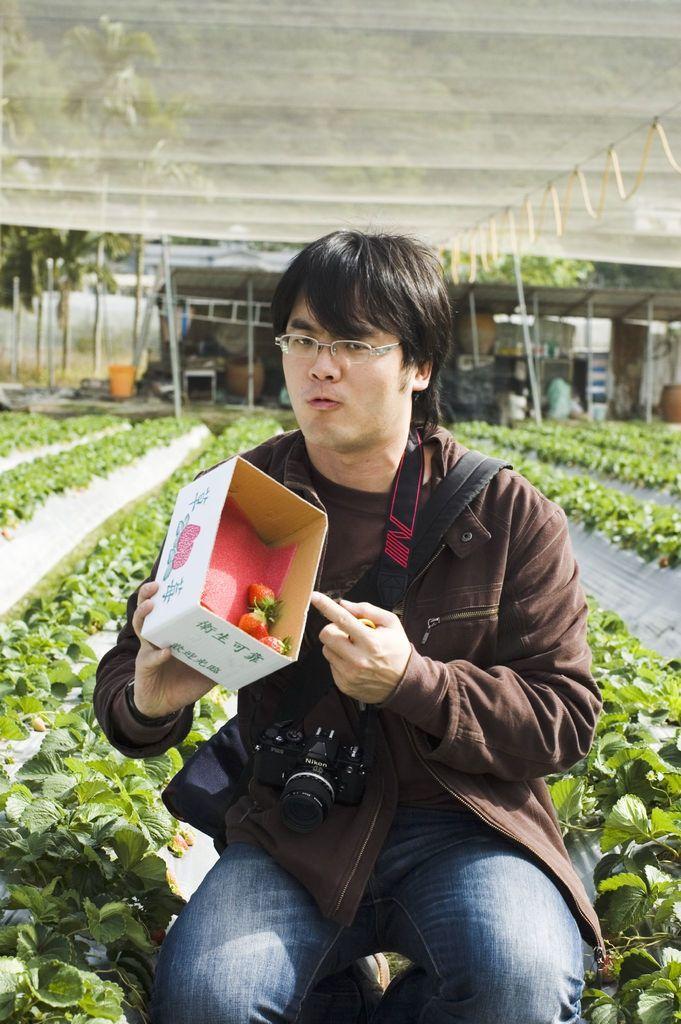Could you give a brief overview of what you see in this image? In front of the image there is a person wearing a camera and he is holding the strawberry box in his hand. There are plants and strawberries. In the background of the image there is a tent, trees, building and there are a few objects. 